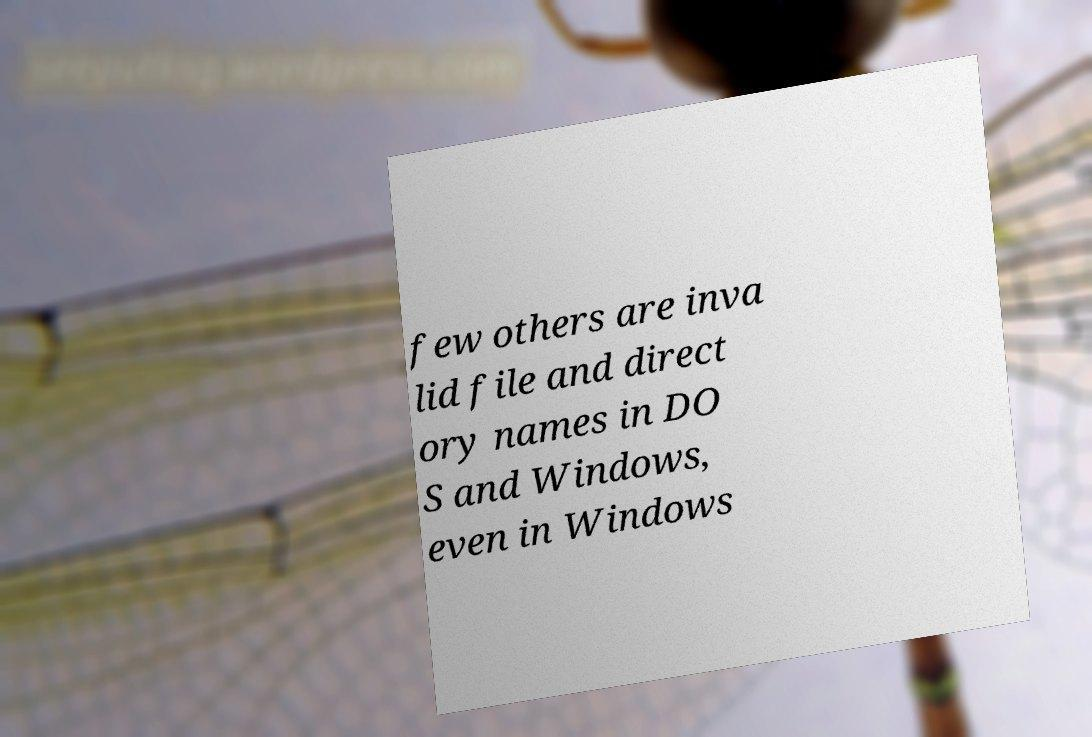Can you read and provide the text displayed in the image?This photo seems to have some interesting text. Can you extract and type it out for me? few others are inva lid file and direct ory names in DO S and Windows, even in Windows 